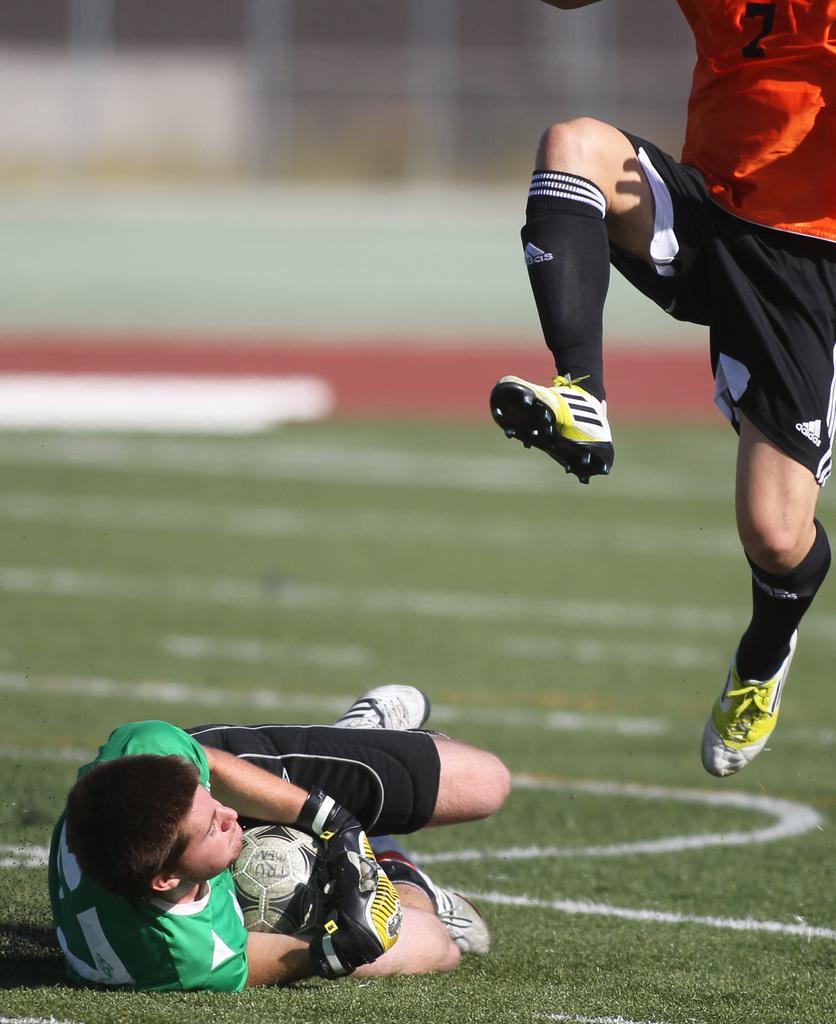How would you summarize this image in a sentence or two? There is a man with green t-shirt on the ground holding a ball in his hand. There is another man in the air with orange t-shirt. 